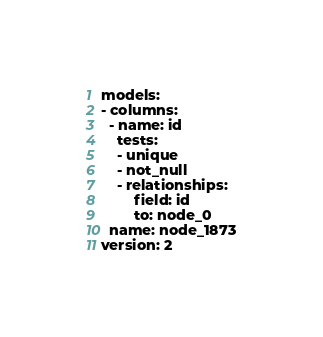<code> <loc_0><loc_0><loc_500><loc_500><_YAML_>models:
- columns:
  - name: id
    tests:
    - unique
    - not_null
    - relationships:
        field: id
        to: node_0
  name: node_1873
version: 2
</code> 